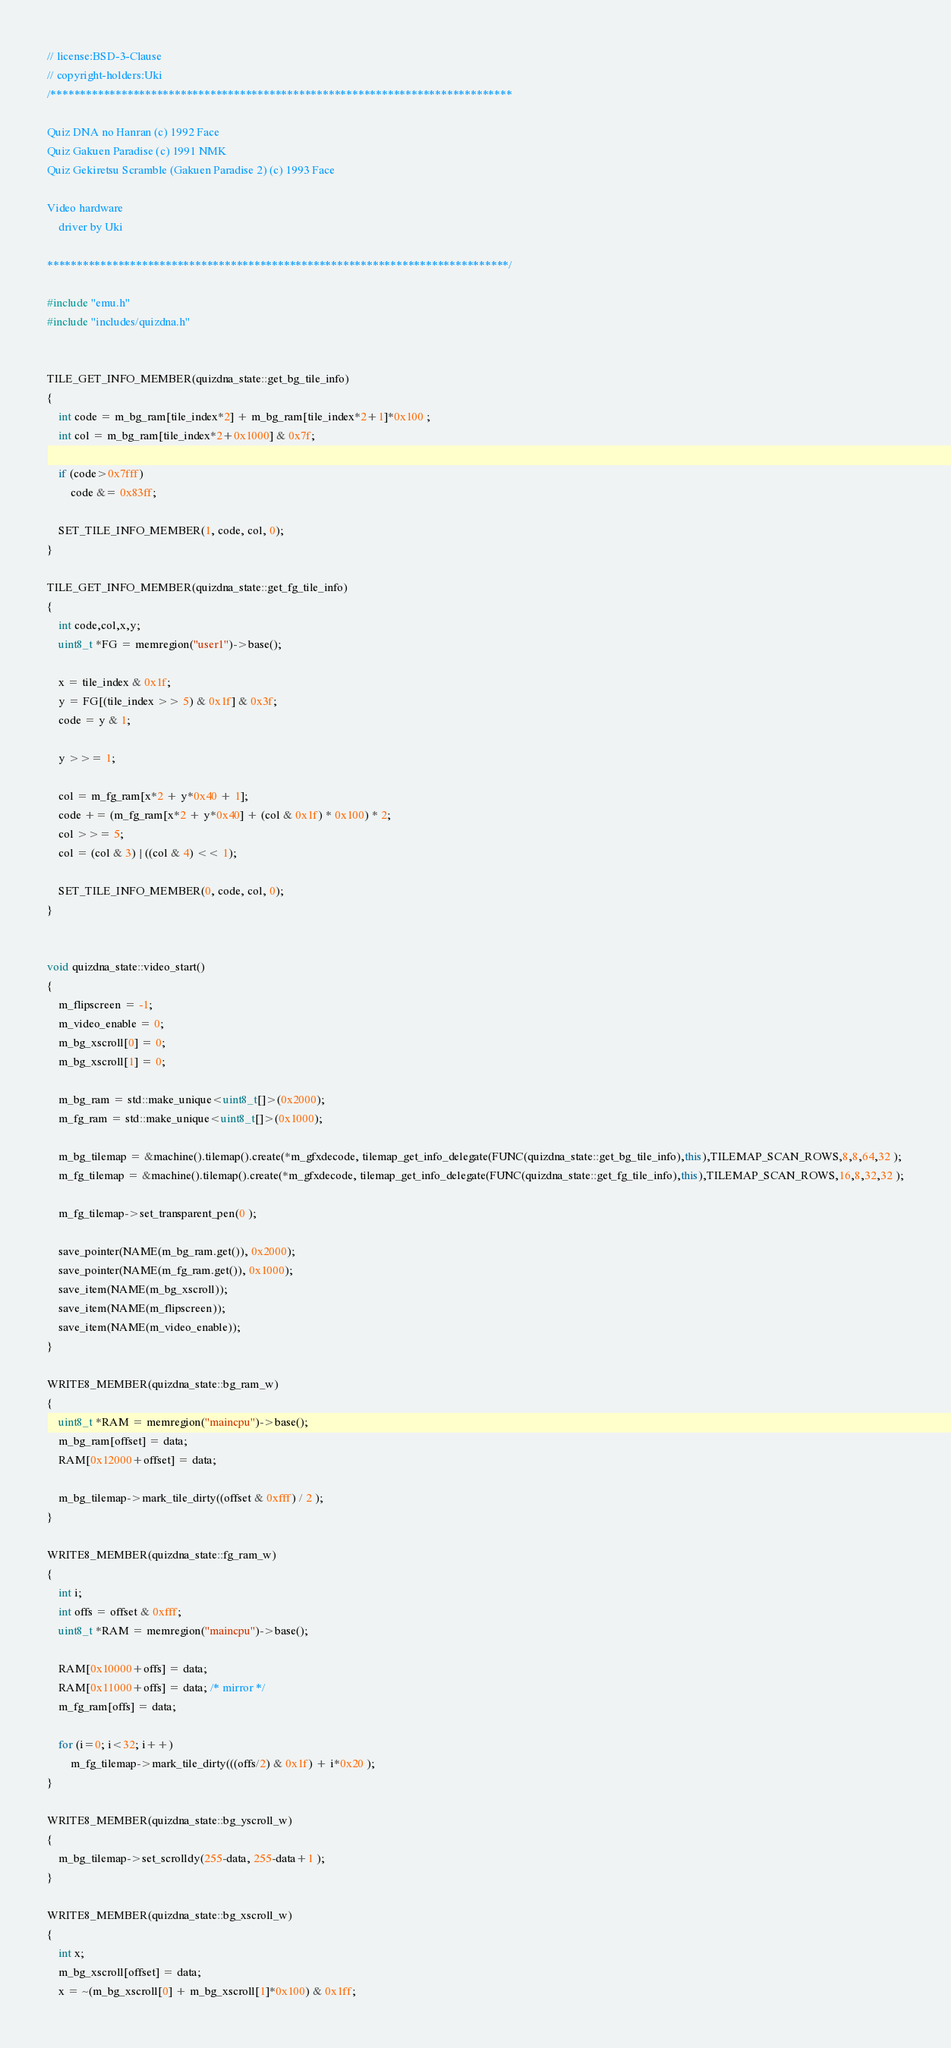<code> <loc_0><loc_0><loc_500><loc_500><_C++_>// license:BSD-3-Clause
// copyright-holders:Uki
/******************************************************************************

Quiz DNA no Hanran (c) 1992 Face
Quiz Gakuen Paradise (c) 1991 NMK
Quiz Gekiretsu Scramble (Gakuen Paradise 2) (c) 1993 Face

Video hardware
    driver by Uki

******************************************************************************/

#include "emu.h"
#include "includes/quizdna.h"


TILE_GET_INFO_MEMBER(quizdna_state::get_bg_tile_info)
{
	int code = m_bg_ram[tile_index*2] + m_bg_ram[tile_index*2+1]*0x100 ;
	int col = m_bg_ram[tile_index*2+0x1000] & 0x7f;

	if (code>0x7fff)
		code &= 0x83ff;

	SET_TILE_INFO_MEMBER(1, code, col, 0);
}

TILE_GET_INFO_MEMBER(quizdna_state::get_fg_tile_info)
{
	int code,col,x,y;
	uint8_t *FG = memregion("user1")->base();

	x = tile_index & 0x1f;
	y = FG[(tile_index >> 5) & 0x1f] & 0x3f;
	code = y & 1;

	y >>= 1;

	col = m_fg_ram[x*2 + y*0x40 + 1];
	code += (m_fg_ram[x*2 + y*0x40] + (col & 0x1f) * 0x100) * 2;
	col >>= 5;
	col = (col & 3) | ((col & 4) << 1);

	SET_TILE_INFO_MEMBER(0, code, col, 0);
}


void quizdna_state::video_start()
{
	m_flipscreen = -1;
	m_video_enable = 0;
	m_bg_xscroll[0] = 0;
	m_bg_xscroll[1] = 0;

	m_bg_ram = std::make_unique<uint8_t[]>(0x2000);
	m_fg_ram = std::make_unique<uint8_t[]>(0x1000);

	m_bg_tilemap = &machine().tilemap().create(*m_gfxdecode, tilemap_get_info_delegate(FUNC(quizdna_state::get_bg_tile_info),this),TILEMAP_SCAN_ROWS,8,8,64,32 );
	m_fg_tilemap = &machine().tilemap().create(*m_gfxdecode, tilemap_get_info_delegate(FUNC(quizdna_state::get_fg_tile_info),this),TILEMAP_SCAN_ROWS,16,8,32,32 );

	m_fg_tilemap->set_transparent_pen(0 );

	save_pointer(NAME(m_bg_ram.get()), 0x2000);
	save_pointer(NAME(m_fg_ram.get()), 0x1000);
	save_item(NAME(m_bg_xscroll));
	save_item(NAME(m_flipscreen));
	save_item(NAME(m_video_enable));
}

WRITE8_MEMBER(quizdna_state::bg_ram_w)
{
	uint8_t *RAM = memregion("maincpu")->base();
	m_bg_ram[offset] = data;
	RAM[0x12000+offset] = data;

	m_bg_tilemap->mark_tile_dirty((offset & 0xfff) / 2 );
}

WRITE8_MEMBER(quizdna_state::fg_ram_w)
{
	int i;
	int offs = offset & 0xfff;
	uint8_t *RAM = memregion("maincpu")->base();

	RAM[0x10000+offs] = data;
	RAM[0x11000+offs] = data; /* mirror */
	m_fg_ram[offs] = data;

	for (i=0; i<32; i++)
		m_fg_tilemap->mark_tile_dirty(((offs/2) & 0x1f) + i*0x20 );
}

WRITE8_MEMBER(quizdna_state::bg_yscroll_w)
{
	m_bg_tilemap->set_scrolldy(255-data, 255-data+1 );
}

WRITE8_MEMBER(quizdna_state::bg_xscroll_w)
{
	int x;
	m_bg_xscroll[offset] = data;
	x = ~(m_bg_xscroll[0] + m_bg_xscroll[1]*0x100) & 0x1ff;
</code> 